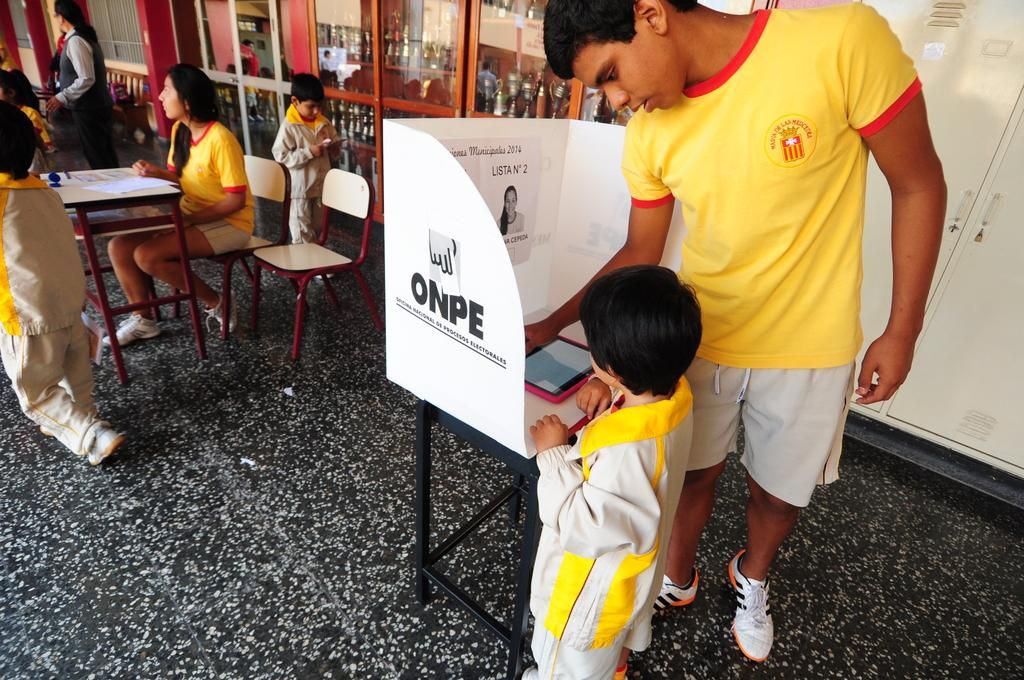Who is standing beside a small boy in the image? There is a man standing beside a small boy in the image. What is the man doing in the image? The man is operating a machine in the image. Who is sitting in a chair in the image? There is a woman sitting in a chair in the image. How many people are standing in the image? There are two people standing in the image, a man and a boy. What is the boy doing in the image? The boy is operating a phone in the image. What type of toothpaste is being used by the company in the image? There is no toothpaste or company present in the image. How does the heat affect the people in the image? There is no mention of heat or its effects in the image. 